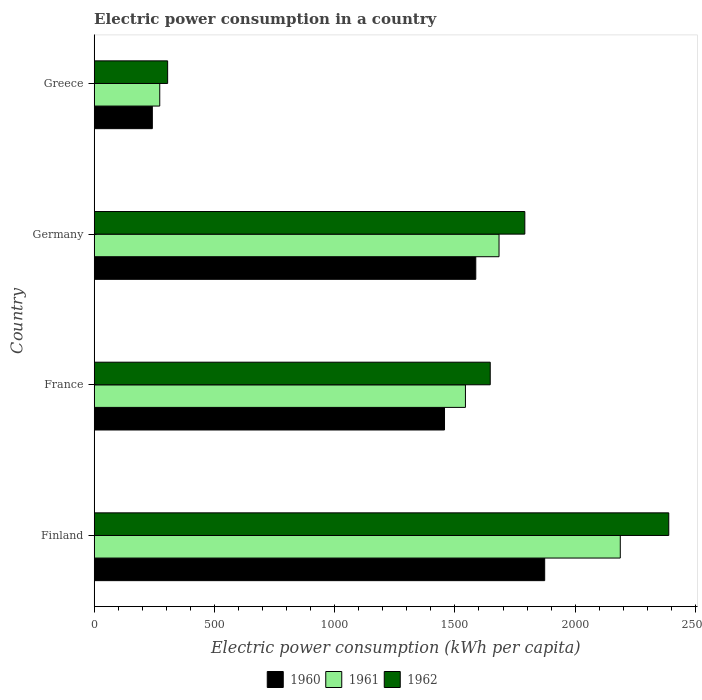How many groups of bars are there?
Keep it short and to the point. 4. Are the number of bars per tick equal to the number of legend labels?
Keep it short and to the point. Yes. How many bars are there on the 4th tick from the bottom?
Give a very brief answer. 3. In how many cases, is the number of bars for a given country not equal to the number of legend labels?
Your answer should be compact. 0. What is the electric power consumption in in 1960 in Finland?
Provide a succinct answer. 1873.29. Across all countries, what is the maximum electric power consumption in in 1962?
Give a very brief answer. 2389.21. Across all countries, what is the minimum electric power consumption in in 1961?
Ensure brevity in your answer.  272.56. In which country was the electric power consumption in in 1961 minimum?
Provide a short and direct response. Greece. What is the total electric power consumption in in 1962 in the graph?
Your response must be concise. 6132.12. What is the difference between the electric power consumption in in 1961 in Finland and that in Germany?
Make the answer very short. 504.21. What is the difference between the electric power consumption in in 1961 in Greece and the electric power consumption in in 1962 in Germany?
Provide a succinct answer. -1518.12. What is the average electric power consumption in in 1961 per country?
Provide a succinct answer. 1421.83. What is the difference between the electric power consumption in in 1961 and electric power consumption in in 1960 in Greece?
Offer a terse response. 30.84. In how many countries, is the electric power consumption in in 1962 greater than 1400 kWh per capita?
Keep it short and to the point. 3. What is the ratio of the electric power consumption in in 1960 in France to that in Germany?
Provide a short and direct response. 0.92. Is the electric power consumption in in 1961 in Germany less than that in Greece?
Give a very brief answer. No. Is the difference between the electric power consumption in in 1961 in Germany and Greece greater than the difference between the electric power consumption in in 1960 in Germany and Greece?
Offer a terse response. Yes. What is the difference between the highest and the second highest electric power consumption in in 1960?
Provide a succinct answer. 286.54. What is the difference between the highest and the lowest electric power consumption in in 1960?
Keep it short and to the point. 1631.57. What does the 2nd bar from the top in Germany represents?
Provide a short and direct response. 1961. Are all the bars in the graph horizontal?
Your response must be concise. Yes. Does the graph contain grids?
Provide a succinct answer. No. How many legend labels are there?
Make the answer very short. 3. How are the legend labels stacked?
Your response must be concise. Horizontal. What is the title of the graph?
Offer a very short reply. Electric power consumption in a country. Does "1977" appear as one of the legend labels in the graph?
Ensure brevity in your answer.  No. What is the label or title of the X-axis?
Provide a succinct answer. Electric power consumption (kWh per capita). What is the Electric power consumption (kWh per capita) in 1960 in Finland?
Your response must be concise. 1873.29. What is the Electric power consumption (kWh per capita) in 1961 in Finland?
Your answer should be very brief. 2187.62. What is the Electric power consumption (kWh per capita) of 1962 in Finland?
Offer a very short reply. 2389.21. What is the Electric power consumption (kWh per capita) of 1960 in France?
Give a very brief answer. 1456.69. What is the Electric power consumption (kWh per capita) in 1961 in France?
Provide a short and direct response. 1543.71. What is the Electric power consumption (kWh per capita) of 1962 in France?
Your answer should be very brief. 1646.83. What is the Electric power consumption (kWh per capita) in 1960 in Germany?
Your answer should be very brief. 1586.75. What is the Electric power consumption (kWh per capita) of 1961 in Germany?
Make the answer very short. 1683.41. What is the Electric power consumption (kWh per capita) of 1962 in Germany?
Your response must be concise. 1790.69. What is the Electric power consumption (kWh per capita) of 1960 in Greece?
Provide a succinct answer. 241.73. What is the Electric power consumption (kWh per capita) of 1961 in Greece?
Offer a very short reply. 272.56. What is the Electric power consumption (kWh per capita) in 1962 in Greece?
Offer a very short reply. 305.39. Across all countries, what is the maximum Electric power consumption (kWh per capita) of 1960?
Provide a succinct answer. 1873.29. Across all countries, what is the maximum Electric power consumption (kWh per capita) of 1961?
Give a very brief answer. 2187.62. Across all countries, what is the maximum Electric power consumption (kWh per capita) in 1962?
Provide a short and direct response. 2389.21. Across all countries, what is the minimum Electric power consumption (kWh per capita) of 1960?
Your answer should be very brief. 241.73. Across all countries, what is the minimum Electric power consumption (kWh per capita) in 1961?
Offer a very short reply. 272.56. Across all countries, what is the minimum Electric power consumption (kWh per capita) of 1962?
Offer a very short reply. 305.39. What is the total Electric power consumption (kWh per capita) of 1960 in the graph?
Offer a terse response. 5158.46. What is the total Electric power consumption (kWh per capita) in 1961 in the graph?
Provide a short and direct response. 5687.31. What is the total Electric power consumption (kWh per capita) in 1962 in the graph?
Provide a succinct answer. 6132.12. What is the difference between the Electric power consumption (kWh per capita) in 1960 in Finland and that in France?
Your answer should be compact. 416.6. What is the difference between the Electric power consumption (kWh per capita) of 1961 in Finland and that in France?
Keep it short and to the point. 643.91. What is the difference between the Electric power consumption (kWh per capita) in 1962 in Finland and that in France?
Ensure brevity in your answer.  742.38. What is the difference between the Electric power consumption (kWh per capita) of 1960 in Finland and that in Germany?
Give a very brief answer. 286.54. What is the difference between the Electric power consumption (kWh per capita) in 1961 in Finland and that in Germany?
Provide a succinct answer. 504.21. What is the difference between the Electric power consumption (kWh per capita) in 1962 in Finland and that in Germany?
Your response must be concise. 598.52. What is the difference between the Electric power consumption (kWh per capita) in 1960 in Finland and that in Greece?
Provide a succinct answer. 1631.57. What is the difference between the Electric power consumption (kWh per capita) of 1961 in Finland and that in Greece?
Provide a short and direct response. 1915.06. What is the difference between the Electric power consumption (kWh per capita) in 1962 in Finland and that in Greece?
Make the answer very short. 2083.82. What is the difference between the Electric power consumption (kWh per capita) of 1960 in France and that in Germany?
Your answer should be very brief. -130.06. What is the difference between the Electric power consumption (kWh per capita) in 1961 in France and that in Germany?
Offer a very short reply. -139.7. What is the difference between the Electric power consumption (kWh per capita) of 1962 in France and that in Germany?
Your answer should be very brief. -143.85. What is the difference between the Electric power consumption (kWh per capita) in 1960 in France and that in Greece?
Your response must be concise. 1214.97. What is the difference between the Electric power consumption (kWh per capita) in 1961 in France and that in Greece?
Your answer should be very brief. 1271.15. What is the difference between the Electric power consumption (kWh per capita) in 1962 in France and that in Greece?
Provide a succinct answer. 1341.44. What is the difference between the Electric power consumption (kWh per capita) of 1960 in Germany and that in Greece?
Keep it short and to the point. 1345.02. What is the difference between the Electric power consumption (kWh per capita) of 1961 in Germany and that in Greece?
Your response must be concise. 1410.85. What is the difference between the Electric power consumption (kWh per capita) in 1962 in Germany and that in Greece?
Your answer should be very brief. 1485.3. What is the difference between the Electric power consumption (kWh per capita) in 1960 in Finland and the Electric power consumption (kWh per capita) in 1961 in France?
Make the answer very short. 329.58. What is the difference between the Electric power consumption (kWh per capita) in 1960 in Finland and the Electric power consumption (kWh per capita) in 1962 in France?
Ensure brevity in your answer.  226.46. What is the difference between the Electric power consumption (kWh per capita) of 1961 in Finland and the Electric power consumption (kWh per capita) of 1962 in France?
Your answer should be compact. 540.79. What is the difference between the Electric power consumption (kWh per capita) in 1960 in Finland and the Electric power consumption (kWh per capita) in 1961 in Germany?
Your response must be concise. 189.88. What is the difference between the Electric power consumption (kWh per capita) of 1960 in Finland and the Electric power consumption (kWh per capita) of 1962 in Germany?
Provide a short and direct response. 82.61. What is the difference between the Electric power consumption (kWh per capita) in 1961 in Finland and the Electric power consumption (kWh per capita) in 1962 in Germany?
Keep it short and to the point. 396.94. What is the difference between the Electric power consumption (kWh per capita) in 1960 in Finland and the Electric power consumption (kWh per capita) in 1961 in Greece?
Keep it short and to the point. 1600.73. What is the difference between the Electric power consumption (kWh per capita) in 1960 in Finland and the Electric power consumption (kWh per capita) in 1962 in Greece?
Ensure brevity in your answer.  1567.9. What is the difference between the Electric power consumption (kWh per capita) of 1961 in Finland and the Electric power consumption (kWh per capita) of 1962 in Greece?
Make the answer very short. 1882.23. What is the difference between the Electric power consumption (kWh per capita) of 1960 in France and the Electric power consumption (kWh per capita) of 1961 in Germany?
Provide a short and direct response. -226.72. What is the difference between the Electric power consumption (kWh per capita) in 1960 in France and the Electric power consumption (kWh per capita) in 1962 in Germany?
Ensure brevity in your answer.  -333.99. What is the difference between the Electric power consumption (kWh per capita) in 1961 in France and the Electric power consumption (kWh per capita) in 1962 in Germany?
Offer a very short reply. -246.98. What is the difference between the Electric power consumption (kWh per capita) of 1960 in France and the Electric power consumption (kWh per capita) of 1961 in Greece?
Your answer should be compact. 1184.13. What is the difference between the Electric power consumption (kWh per capita) in 1960 in France and the Electric power consumption (kWh per capita) in 1962 in Greece?
Ensure brevity in your answer.  1151.3. What is the difference between the Electric power consumption (kWh per capita) in 1961 in France and the Electric power consumption (kWh per capita) in 1962 in Greece?
Offer a terse response. 1238.32. What is the difference between the Electric power consumption (kWh per capita) in 1960 in Germany and the Electric power consumption (kWh per capita) in 1961 in Greece?
Offer a terse response. 1314.19. What is the difference between the Electric power consumption (kWh per capita) of 1960 in Germany and the Electric power consumption (kWh per capita) of 1962 in Greece?
Your response must be concise. 1281.36. What is the difference between the Electric power consumption (kWh per capita) in 1961 in Germany and the Electric power consumption (kWh per capita) in 1962 in Greece?
Provide a succinct answer. 1378.03. What is the average Electric power consumption (kWh per capita) in 1960 per country?
Your answer should be very brief. 1289.62. What is the average Electric power consumption (kWh per capita) in 1961 per country?
Your response must be concise. 1421.83. What is the average Electric power consumption (kWh per capita) in 1962 per country?
Your answer should be compact. 1533.03. What is the difference between the Electric power consumption (kWh per capita) of 1960 and Electric power consumption (kWh per capita) of 1961 in Finland?
Ensure brevity in your answer.  -314.33. What is the difference between the Electric power consumption (kWh per capita) of 1960 and Electric power consumption (kWh per capita) of 1962 in Finland?
Keep it short and to the point. -515.92. What is the difference between the Electric power consumption (kWh per capita) in 1961 and Electric power consumption (kWh per capita) in 1962 in Finland?
Make the answer very short. -201.59. What is the difference between the Electric power consumption (kWh per capita) of 1960 and Electric power consumption (kWh per capita) of 1961 in France?
Give a very brief answer. -87.02. What is the difference between the Electric power consumption (kWh per capita) in 1960 and Electric power consumption (kWh per capita) in 1962 in France?
Make the answer very short. -190.14. What is the difference between the Electric power consumption (kWh per capita) of 1961 and Electric power consumption (kWh per capita) of 1962 in France?
Provide a succinct answer. -103.12. What is the difference between the Electric power consumption (kWh per capita) of 1960 and Electric power consumption (kWh per capita) of 1961 in Germany?
Keep it short and to the point. -96.67. What is the difference between the Electric power consumption (kWh per capita) of 1960 and Electric power consumption (kWh per capita) of 1962 in Germany?
Ensure brevity in your answer.  -203.94. What is the difference between the Electric power consumption (kWh per capita) of 1961 and Electric power consumption (kWh per capita) of 1962 in Germany?
Your answer should be compact. -107.27. What is the difference between the Electric power consumption (kWh per capita) in 1960 and Electric power consumption (kWh per capita) in 1961 in Greece?
Offer a terse response. -30.84. What is the difference between the Electric power consumption (kWh per capita) of 1960 and Electric power consumption (kWh per capita) of 1962 in Greece?
Make the answer very short. -63.66. What is the difference between the Electric power consumption (kWh per capita) in 1961 and Electric power consumption (kWh per capita) in 1962 in Greece?
Keep it short and to the point. -32.83. What is the ratio of the Electric power consumption (kWh per capita) of 1960 in Finland to that in France?
Your answer should be very brief. 1.29. What is the ratio of the Electric power consumption (kWh per capita) of 1961 in Finland to that in France?
Your answer should be compact. 1.42. What is the ratio of the Electric power consumption (kWh per capita) in 1962 in Finland to that in France?
Make the answer very short. 1.45. What is the ratio of the Electric power consumption (kWh per capita) of 1960 in Finland to that in Germany?
Ensure brevity in your answer.  1.18. What is the ratio of the Electric power consumption (kWh per capita) of 1961 in Finland to that in Germany?
Your answer should be very brief. 1.3. What is the ratio of the Electric power consumption (kWh per capita) of 1962 in Finland to that in Germany?
Provide a succinct answer. 1.33. What is the ratio of the Electric power consumption (kWh per capita) of 1960 in Finland to that in Greece?
Offer a very short reply. 7.75. What is the ratio of the Electric power consumption (kWh per capita) in 1961 in Finland to that in Greece?
Provide a short and direct response. 8.03. What is the ratio of the Electric power consumption (kWh per capita) in 1962 in Finland to that in Greece?
Provide a short and direct response. 7.82. What is the ratio of the Electric power consumption (kWh per capita) in 1960 in France to that in Germany?
Offer a terse response. 0.92. What is the ratio of the Electric power consumption (kWh per capita) of 1961 in France to that in Germany?
Give a very brief answer. 0.92. What is the ratio of the Electric power consumption (kWh per capita) of 1962 in France to that in Germany?
Give a very brief answer. 0.92. What is the ratio of the Electric power consumption (kWh per capita) in 1960 in France to that in Greece?
Your response must be concise. 6.03. What is the ratio of the Electric power consumption (kWh per capita) in 1961 in France to that in Greece?
Offer a very short reply. 5.66. What is the ratio of the Electric power consumption (kWh per capita) of 1962 in France to that in Greece?
Ensure brevity in your answer.  5.39. What is the ratio of the Electric power consumption (kWh per capita) in 1960 in Germany to that in Greece?
Provide a succinct answer. 6.56. What is the ratio of the Electric power consumption (kWh per capita) in 1961 in Germany to that in Greece?
Ensure brevity in your answer.  6.18. What is the ratio of the Electric power consumption (kWh per capita) in 1962 in Germany to that in Greece?
Your response must be concise. 5.86. What is the difference between the highest and the second highest Electric power consumption (kWh per capita) of 1960?
Keep it short and to the point. 286.54. What is the difference between the highest and the second highest Electric power consumption (kWh per capita) in 1961?
Keep it short and to the point. 504.21. What is the difference between the highest and the second highest Electric power consumption (kWh per capita) in 1962?
Provide a succinct answer. 598.52. What is the difference between the highest and the lowest Electric power consumption (kWh per capita) in 1960?
Keep it short and to the point. 1631.57. What is the difference between the highest and the lowest Electric power consumption (kWh per capita) of 1961?
Offer a very short reply. 1915.06. What is the difference between the highest and the lowest Electric power consumption (kWh per capita) in 1962?
Your answer should be compact. 2083.82. 